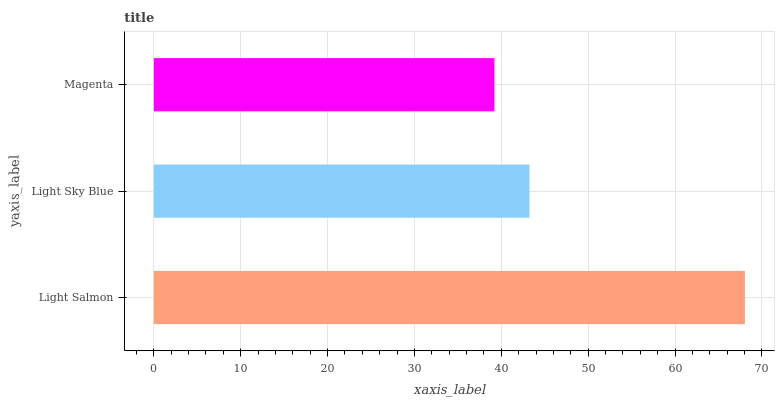Is Magenta the minimum?
Answer yes or no. Yes. Is Light Salmon the maximum?
Answer yes or no. Yes. Is Light Sky Blue the minimum?
Answer yes or no. No. Is Light Sky Blue the maximum?
Answer yes or no. No. Is Light Salmon greater than Light Sky Blue?
Answer yes or no. Yes. Is Light Sky Blue less than Light Salmon?
Answer yes or no. Yes. Is Light Sky Blue greater than Light Salmon?
Answer yes or no. No. Is Light Salmon less than Light Sky Blue?
Answer yes or no. No. Is Light Sky Blue the high median?
Answer yes or no. Yes. Is Light Sky Blue the low median?
Answer yes or no. Yes. Is Magenta the high median?
Answer yes or no. No. Is Light Salmon the low median?
Answer yes or no. No. 